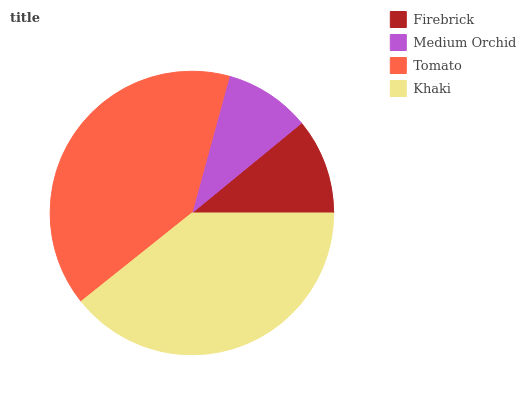Is Medium Orchid the minimum?
Answer yes or no. Yes. Is Tomato the maximum?
Answer yes or no. Yes. Is Tomato the minimum?
Answer yes or no. No. Is Medium Orchid the maximum?
Answer yes or no. No. Is Tomato greater than Medium Orchid?
Answer yes or no. Yes. Is Medium Orchid less than Tomato?
Answer yes or no. Yes. Is Medium Orchid greater than Tomato?
Answer yes or no. No. Is Tomato less than Medium Orchid?
Answer yes or no. No. Is Khaki the high median?
Answer yes or no. Yes. Is Firebrick the low median?
Answer yes or no. Yes. Is Tomato the high median?
Answer yes or no. No. Is Medium Orchid the low median?
Answer yes or no. No. 